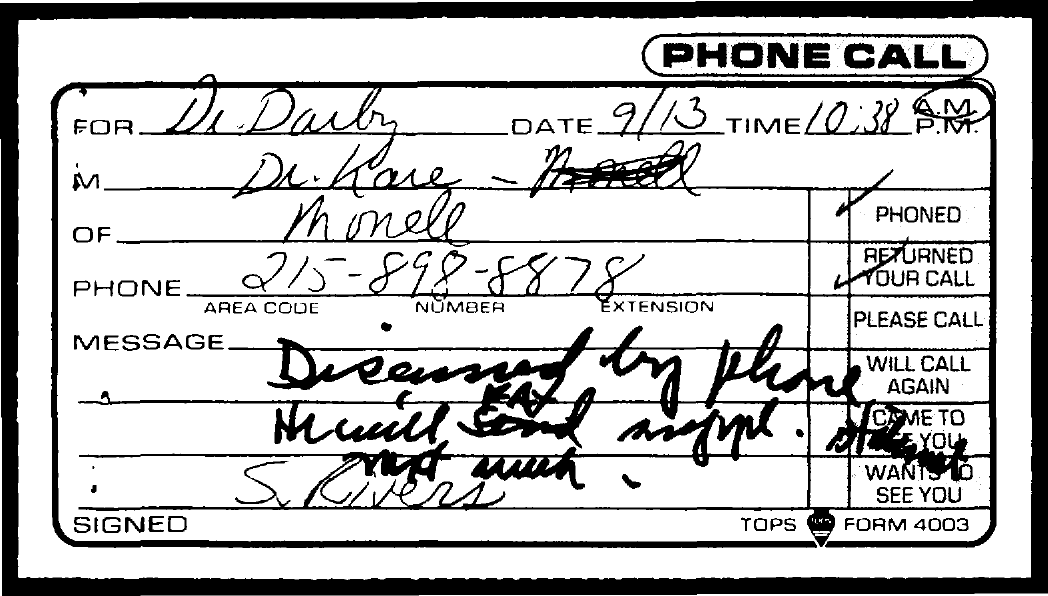Outline some significant characteristics in this image. The date mentioned in the document is September 13th. The area code is 215. 